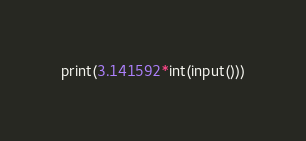<code> <loc_0><loc_0><loc_500><loc_500><_Python_>print(3.141592*int(input()))</code> 